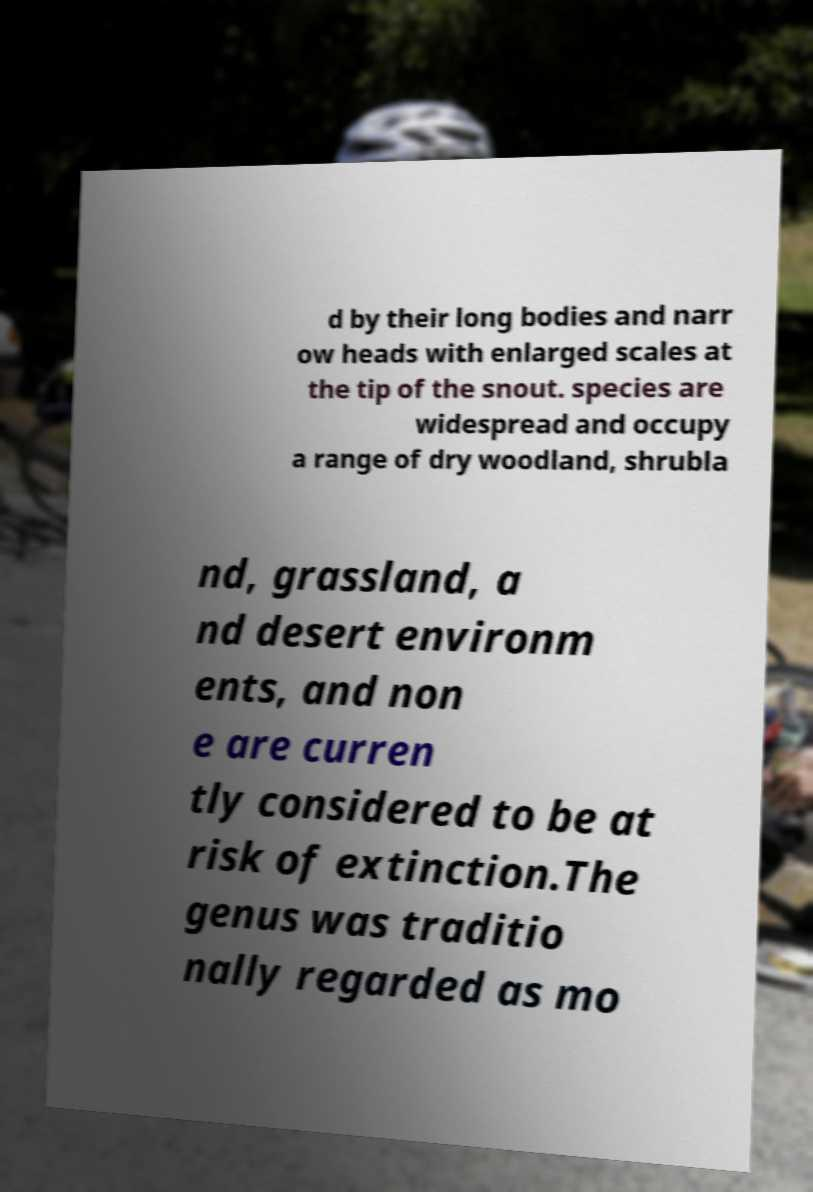There's text embedded in this image that I need extracted. Can you transcribe it verbatim? d by their long bodies and narr ow heads with enlarged scales at the tip of the snout. species are widespread and occupy a range of dry woodland, shrubla nd, grassland, a nd desert environm ents, and non e are curren tly considered to be at risk of extinction.The genus was traditio nally regarded as mo 